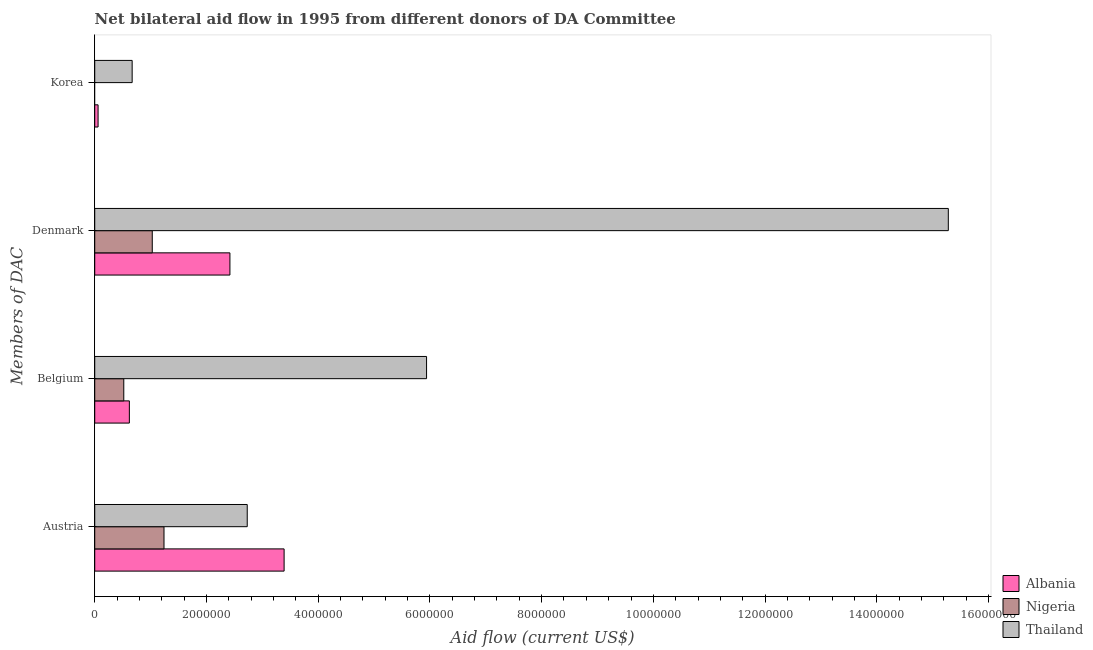How many different coloured bars are there?
Offer a very short reply. 3. How many groups of bars are there?
Your response must be concise. 4. How many bars are there on the 3rd tick from the bottom?
Make the answer very short. 3. What is the amount of aid given by belgium in Albania?
Your response must be concise. 6.20e+05. Across all countries, what is the maximum amount of aid given by korea?
Provide a short and direct response. 6.70e+05. Across all countries, what is the minimum amount of aid given by korea?
Offer a terse response. 0. In which country was the amount of aid given by denmark maximum?
Offer a terse response. Thailand. What is the total amount of aid given by belgium in the graph?
Provide a succinct answer. 7.08e+06. What is the difference between the amount of aid given by austria in Nigeria and that in Albania?
Make the answer very short. -2.15e+06. What is the difference between the amount of aid given by denmark in Albania and the amount of aid given by austria in Nigeria?
Ensure brevity in your answer.  1.18e+06. What is the average amount of aid given by denmark per country?
Provide a short and direct response. 6.24e+06. What is the difference between the amount of aid given by korea and amount of aid given by belgium in Albania?
Ensure brevity in your answer.  -5.60e+05. What is the ratio of the amount of aid given by belgium in Thailand to that in Nigeria?
Keep it short and to the point. 11.42. Is the amount of aid given by denmark in Nigeria less than that in Albania?
Ensure brevity in your answer.  Yes. Is the difference between the amount of aid given by austria in Thailand and Nigeria greater than the difference between the amount of aid given by belgium in Thailand and Nigeria?
Your answer should be very brief. No. What is the difference between the highest and the second highest amount of aid given by denmark?
Offer a terse response. 1.29e+07. What is the difference between the highest and the lowest amount of aid given by austria?
Provide a succinct answer. 2.15e+06. Is the sum of the amount of aid given by austria in Nigeria and Thailand greater than the maximum amount of aid given by belgium across all countries?
Your answer should be very brief. No. Is it the case that in every country, the sum of the amount of aid given by austria and amount of aid given by belgium is greater than the sum of amount of aid given by denmark and amount of aid given by korea?
Provide a succinct answer. No. Is it the case that in every country, the sum of the amount of aid given by austria and amount of aid given by belgium is greater than the amount of aid given by denmark?
Provide a short and direct response. No. Are all the bars in the graph horizontal?
Offer a terse response. Yes. Are the values on the major ticks of X-axis written in scientific E-notation?
Offer a terse response. No. Does the graph contain grids?
Keep it short and to the point. No. Where does the legend appear in the graph?
Your response must be concise. Bottom right. How are the legend labels stacked?
Give a very brief answer. Vertical. What is the title of the graph?
Give a very brief answer. Net bilateral aid flow in 1995 from different donors of DA Committee. What is the label or title of the X-axis?
Make the answer very short. Aid flow (current US$). What is the label or title of the Y-axis?
Offer a very short reply. Members of DAC. What is the Aid flow (current US$) of Albania in Austria?
Give a very brief answer. 3.39e+06. What is the Aid flow (current US$) of Nigeria in Austria?
Ensure brevity in your answer.  1.24e+06. What is the Aid flow (current US$) in Thailand in Austria?
Make the answer very short. 2.73e+06. What is the Aid flow (current US$) of Albania in Belgium?
Offer a very short reply. 6.20e+05. What is the Aid flow (current US$) of Nigeria in Belgium?
Offer a very short reply. 5.20e+05. What is the Aid flow (current US$) of Thailand in Belgium?
Your answer should be very brief. 5.94e+06. What is the Aid flow (current US$) in Albania in Denmark?
Provide a short and direct response. 2.42e+06. What is the Aid flow (current US$) of Nigeria in Denmark?
Give a very brief answer. 1.03e+06. What is the Aid flow (current US$) of Thailand in Denmark?
Make the answer very short. 1.53e+07. What is the Aid flow (current US$) in Albania in Korea?
Give a very brief answer. 6.00e+04. What is the Aid flow (current US$) of Thailand in Korea?
Provide a short and direct response. 6.70e+05. Across all Members of DAC, what is the maximum Aid flow (current US$) of Albania?
Your answer should be compact. 3.39e+06. Across all Members of DAC, what is the maximum Aid flow (current US$) of Nigeria?
Ensure brevity in your answer.  1.24e+06. Across all Members of DAC, what is the maximum Aid flow (current US$) of Thailand?
Make the answer very short. 1.53e+07. Across all Members of DAC, what is the minimum Aid flow (current US$) of Albania?
Your response must be concise. 6.00e+04. Across all Members of DAC, what is the minimum Aid flow (current US$) of Nigeria?
Make the answer very short. 0. Across all Members of DAC, what is the minimum Aid flow (current US$) in Thailand?
Give a very brief answer. 6.70e+05. What is the total Aid flow (current US$) in Albania in the graph?
Your answer should be compact. 6.49e+06. What is the total Aid flow (current US$) of Nigeria in the graph?
Offer a terse response. 2.79e+06. What is the total Aid flow (current US$) in Thailand in the graph?
Give a very brief answer. 2.46e+07. What is the difference between the Aid flow (current US$) in Albania in Austria and that in Belgium?
Your answer should be compact. 2.77e+06. What is the difference between the Aid flow (current US$) in Nigeria in Austria and that in Belgium?
Offer a very short reply. 7.20e+05. What is the difference between the Aid flow (current US$) in Thailand in Austria and that in Belgium?
Offer a very short reply. -3.21e+06. What is the difference between the Aid flow (current US$) in Albania in Austria and that in Denmark?
Offer a terse response. 9.70e+05. What is the difference between the Aid flow (current US$) of Nigeria in Austria and that in Denmark?
Provide a short and direct response. 2.10e+05. What is the difference between the Aid flow (current US$) in Thailand in Austria and that in Denmark?
Provide a short and direct response. -1.26e+07. What is the difference between the Aid flow (current US$) in Albania in Austria and that in Korea?
Ensure brevity in your answer.  3.33e+06. What is the difference between the Aid flow (current US$) of Thailand in Austria and that in Korea?
Keep it short and to the point. 2.06e+06. What is the difference between the Aid flow (current US$) of Albania in Belgium and that in Denmark?
Offer a very short reply. -1.80e+06. What is the difference between the Aid flow (current US$) in Nigeria in Belgium and that in Denmark?
Provide a short and direct response. -5.10e+05. What is the difference between the Aid flow (current US$) in Thailand in Belgium and that in Denmark?
Keep it short and to the point. -9.34e+06. What is the difference between the Aid flow (current US$) of Albania in Belgium and that in Korea?
Your response must be concise. 5.60e+05. What is the difference between the Aid flow (current US$) of Thailand in Belgium and that in Korea?
Your answer should be compact. 5.27e+06. What is the difference between the Aid flow (current US$) in Albania in Denmark and that in Korea?
Make the answer very short. 2.36e+06. What is the difference between the Aid flow (current US$) of Thailand in Denmark and that in Korea?
Keep it short and to the point. 1.46e+07. What is the difference between the Aid flow (current US$) of Albania in Austria and the Aid flow (current US$) of Nigeria in Belgium?
Offer a terse response. 2.87e+06. What is the difference between the Aid flow (current US$) of Albania in Austria and the Aid flow (current US$) of Thailand in Belgium?
Give a very brief answer. -2.55e+06. What is the difference between the Aid flow (current US$) in Nigeria in Austria and the Aid flow (current US$) in Thailand in Belgium?
Provide a succinct answer. -4.70e+06. What is the difference between the Aid flow (current US$) of Albania in Austria and the Aid flow (current US$) of Nigeria in Denmark?
Make the answer very short. 2.36e+06. What is the difference between the Aid flow (current US$) of Albania in Austria and the Aid flow (current US$) of Thailand in Denmark?
Your response must be concise. -1.19e+07. What is the difference between the Aid flow (current US$) in Nigeria in Austria and the Aid flow (current US$) in Thailand in Denmark?
Your response must be concise. -1.40e+07. What is the difference between the Aid flow (current US$) in Albania in Austria and the Aid flow (current US$) in Thailand in Korea?
Offer a very short reply. 2.72e+06. What is the difference between the Aid flow (current US$) in Nigeria in Austria and the Aid flow (current US$) in Thailand in Korea?
Give a very brief answer. 5.70e+05. What is the difference between the Aid flow (current US$) of Albania in Belgium and the Aid flow (current US$) of Nigeria in Denmark?
Make the answer very short. -4.10e+05. What is the difference between the Aid flow (current US$) in Albania in Belgium and the Aid flow (current US$) in Thailand in Denmark?
Your answer should be compact. -1.47e+07. What is the difference between the Aid flow (current US$) in Nigeria in Belgium and the Aid flow (current US$) in Thailand in Denmark?
Your answer should be compact. -1.48e+07. What is the difference between the Aid flow (current US$) of Albania in Belgium and the Aid flow (current US$) of Thailand in Korea?
Make the answer very short. -5.00e+04. What is the difference between the Aid flow (current US$) of Nigeria in Belgium and the Aid flow (current US$) of Thailand in Korea?
Ensure brevity in your answer.  -1.50e+05. What is the difference between the Aid flow (current US$) in Albania in Denmark and the Aid flow (current US$) in Thailand in Korea?
Provide a short and direct response. 1.75e+06. What is the average Aid flow (current US$) in Albania per Members of DAC?
Your response must be concise. 1.62e+06. What is the average Aid flow (current US$) of Nigeria per Members of DAC?
Ensure brevity in your answer.  6.98e+05. What is the average Aid flow (current US$) in Thailand per Members of DAC?
Your answer should be very brief. 6.16e+06. What is the difference between the Aid flow (current US$) in Albania and Aid flow (current US$) in Nigeria in Austria?
Your response must be concise. 2.15e+06. What is the difference between the Aid flow (current US$) of Nigeria and Aid flow (current US$) of Thailand in Austria?
Make the answer very short. -1.49e+06. What is the difference between the Aid flow (current US$) in Albania and Aid flow (current US$) in Thailand in Belgium?
Your answer should be compact. -5.32e+06. What is the difference between the Aid flow (current US$) in Nigeria and Aid flow (current US$) in Thailand in Belgium?
Keep it short and to the point. -5.42e+06. What is the difference between the Aid flow (current US$) of Albania and Aid flow (current US$) of Nigeria in Denmark?
Your answer should be compact. 1.39e+06. What is the difference between the Aid flow (current US$) of Albania and Aid flow (current US$) of Thailand in Denmark?
Offer a terse response. -1.29e+07. What is the difference between the Aid flow (current US$) of Nigeria and Aid flow (current US$) of Thailand in Denmark?
Your answer should be compact. -1.42e+07. What is the difference between the Aid flow (current US$) of Albania and Aid flow (current US$) of Thailand in Korea?
Your answer should be very brief. -6.10e+05. What is the ratio of the Aid flow (current US$) in Albania in Austria to that in Belgium?
Your response must be concise. 5.47. What is the ratio of the Aid flow (current US$) in Nigeria in Austria to that in Belgium?
Ensure brevity in your answer.  2.38. What is the ratio of the Aid flow (current US$) in Thailand in Austria to that in Belgium?
Your answer should be very brief. 0.46. What is the ratio of the Aid flow (current US$) of Albania in Austria to that in Denmark?
Your answer should be compact. 1.4. What is the ratio of the Aid flow (current US$) in Nigeria in Austria to that in Denmark?
Make the answer very short. 1.2. What is the ratio of the Aid flow (current US$) in Thailand in Austria to that in Denmark?
Make the answer very short. 0.18. What is the ratio of the Aid flow (current US$) of Albania in Austria to that in Korea?
Make the answer very short. 56.5. What is the ratio of the Aid flow (current US$) of Thailand in Austria to that in Korea?
Offer a very short reply. 4.07. What is the ratio of the Aid flow (current US$) of Albania in Belgium to that in Denmark?
Give a very brief answer. 0.26. What is the ratio of the Aid flow (current US$) of Nigeria in Belgium to that in Denmark?
Make the answer very short. 0.5. What is the ratio of the Aid flow (current US$) of Thailand in Belgium to that in Denmark?
Provide a short and direct response. 0.39. What is the ratio of the Aid flow (current US$) of Albania in Belgium to that in Korea?
Provide a short and direct response. 10.33. What is the ratio of the Aid flow (current US$) in Thailand in Belgium to that in Korea?
Offer a very short reply. 8.87. What is the ratio of the Aid flow (current US$) in Albania in Denmark to that in Korea?
Keep it short and to the point. 40.33. What is the ratio of the Aid flow (current US$) of Thailand in Denmark to that in Korea?
Offer a very short reply. 22.81. What is the difference between the highest and the second highest Aid flow (current US$) of Albania?
Provide a short and direct response. 9.70e+05. What is the difference between the highest and the second highest Aid flow (current US$) in Thailand?
Keep it short and to the point. 9.34e+06. What is the difference between the highest and the lowest Aid flow (current US$) of Albania?
Ensure brevity in your answer.  3.33e+06. What is the difference between the highest and the lowest Aid flow (current US$) of Nigeria?
Offer a terse response. 1.24e+06. What is the difference between the highest and the lowest Aid flow (current US$) of Thailand?
Keep it short and to the point. 1.46e+07. 